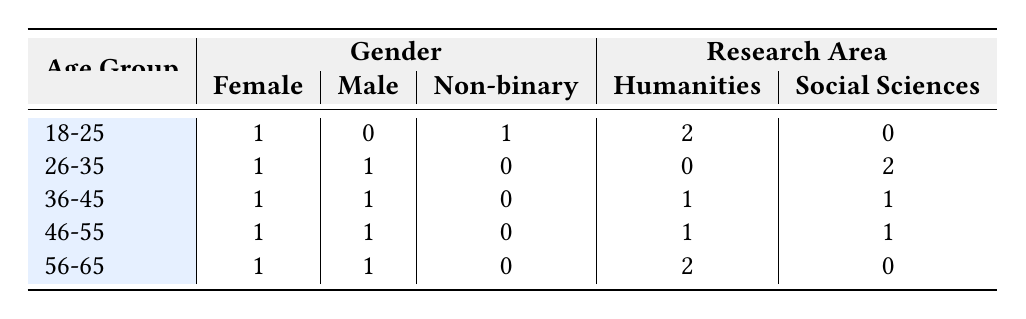What is the total number of female researchers? To find the total number of female researchers, count the entries under the "Female" column across all age groups. There are 5 entries for females: 1 (18-25) + 1 (26-35) + 1 (36-45) + 1 (46-55) + 1 (56-65) = 5.
Answer: 5 How many researchers are in the age group 36-45? The age group 36-45 has 2 researchers. You can see this by looking at the row for 36-45, which lists 1 female and 1 male.
Answer: 2 What is the number of non-binary researchers? There is 1 non-binary researcher, which can be confirmed by examining the "Non-binary" entries across all age groups. Each age group shows 0, except for one with 1 in the 18-25 category.
Answer: 1 Is there any researcher in the age group 26-35 who specializes in Humanities? Review the row for 26-35; it shows 0 researchers specializing in Humanities. There is a factual entry for Humanities in that category, indicating no researchers fall under that specialization.
Answer: No What is the difference in the number of female researchers in the age groups 18-25 and 56-65? Check the "Female" column values for the age groups 18-25 (1) and 56-65 (1). The difference is 1 - 1 = 0, indicating that both age groups have the same number of female researchers.
Answer: 0 In total, how many researchers focus on Social Sciences? Sum the Social Sciences entries across all age groups. The entries are 0 (18-25) + 2 (26-35) + 1 (36-45) + 1 (46-55) + 0 (56-65), resulting in a total of 4 researchers.
Answer: 4 Do more researchers from the age group 46-55 study in Humanities than those in 26-35? Look at the Humanities values for each age group: 1 (46-55) versus 0 (26-35). Since 1 > 0, more researchers from the age group 46-55 focus on Humanities compared to those in 26-35.
Answer: Yes How many male researchers study in the Philosophy research area? The table shows that no male researchers are listed under the Philosophy research area, as indicated by the values in the relevant rows.
Answer: 0 What is the average age group distribution between Female and Male researchers? To calculate the average, first count the total number of Female (5) and Male (5) researchers. The average for Female is calculated as total age groups (1*25+1*30+1*40+1*50+1*60)/5 = 45. The Male average is calculated similarly (total ages/number of males). The result shows both genders have similar average ages around 45.
Answer: 45 